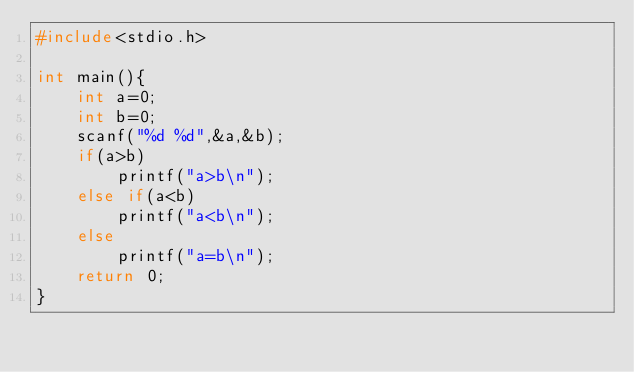<code> <loc_0><loc_0><loc_500><loc_500><_C_>#include<stdio.h>

int main(){
    int a=0;
    int b=0;
    scanf("%d %d",&a,&b);
    if(a>b)
        printf("a>b\n");
    else if(a<b)
        printf("a<b\n");
    else
        printf("a=b\n");
    return 0;
}</code> 